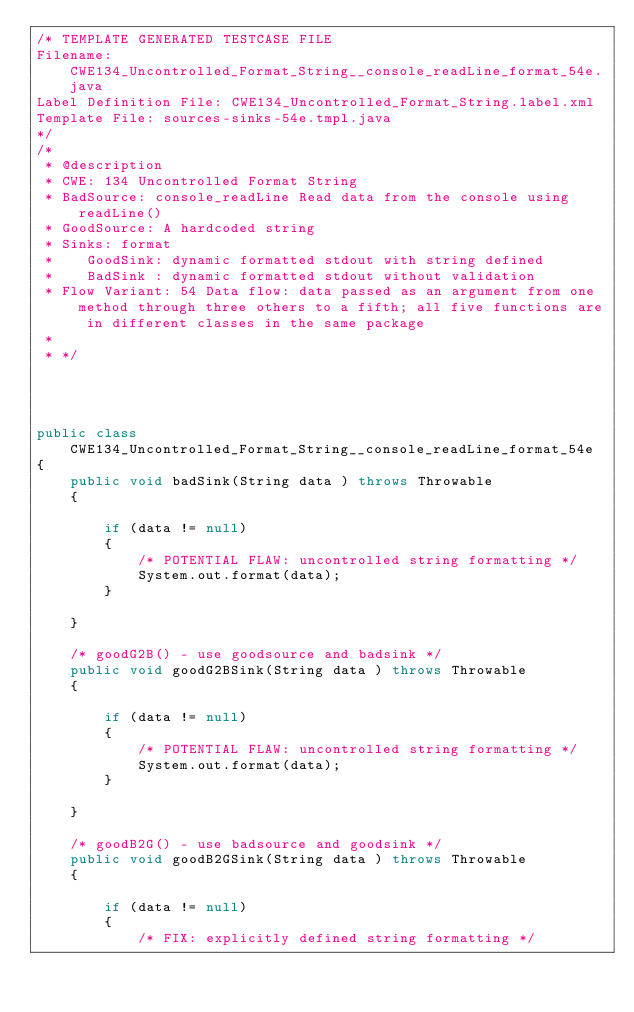<code> <loc_0><loc_0><loc_500><loc_500><_Java_>/* TEMPLATE GENERATED TESTCASE FILE
Filename: CWE134_Uncontrolled_Format_String__console_readLine_format_54e.java
Label Definition File: CWE134_Uncontrolled_Format_String.label.xml
Template File: sources-sinks-54e.tmpl.java
*/
/*
 * @description
 * CWE: 134 Uncontrolled Format String
 * BadSource: console_readLine Read data from the console using readLine()
 * GoodSource: A hardcoded string
 * Sinks: format
 *    GoodSink: dynamic formatted stdout with string defined
 *    BadSink : dynamic formatted stdout without validation
 * Flow Variant: 54 Data flow: data passed as an argument from one method through three others to a fifth; all five functions are in different classes in the same package
 *
 * */




public class CWE134_Uncontrolled_Format_String__console_readLine_format_54e
{
    public void badSink(String data ) throws Throwable
    {

        if (data != null)
        {
            /* POTENTIAL FLAW: uncontrolled string formatting */
            System.out.format(data);
        }

    }

    /* goodG2B() - use goodsource and badsink */
    public void goodG2BSink(String data ) throws Throwable
    {

        if (data != null)
        {
            /* POTENTIAL FLAW: uncontrolled string formatting */
            System.out.format(data);
        }

    }

    /* goodB2G() - use badsource and goodsink */
    public void goodB2GSink(String data ) throws Throwable
    {

        if (data != null)
        {
            /* FIX: explicitly defined string formatting */</code> 